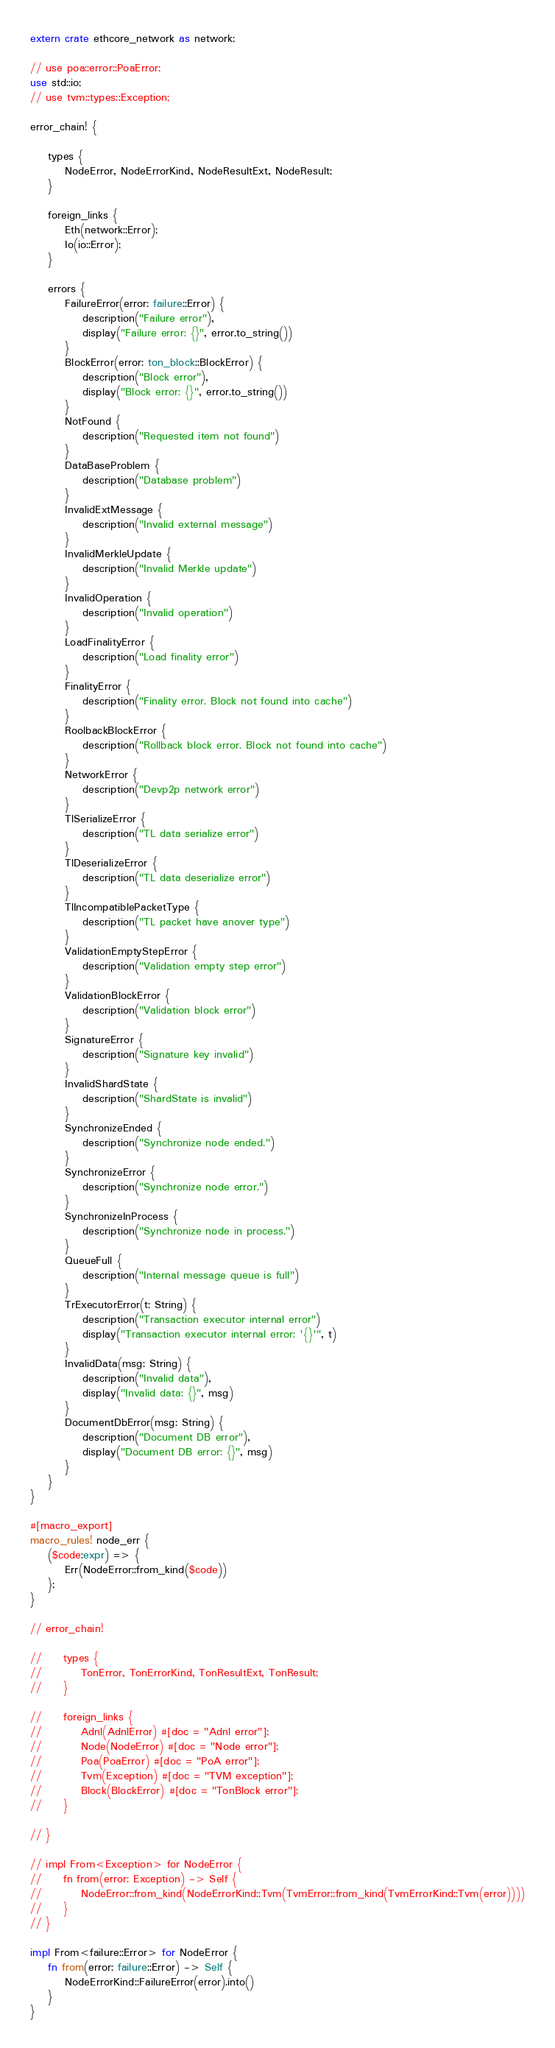Convert code to text. <code><loc_0><loc_0><loc_500><loc_500><_Rust_>extern crate ethcore_network as network;

// use poa::error::PoaError;
use std::io;
// use tvm::types::Exception;

error_chain! {

    types {
        NodeError, NodeErrorKind, NodeResultExt, NodeResult;
    }

    foreign_links {
        Eth(network::Error);
        Io(io::Error);
    }

    errors {
        FailureError(error: failure::Error) {
            description("Failure error"),
            display("Failure error: {}", error.to_string())
        }
        BlockError(error: ton_block::BlockError) {
            description("Block error"),
            display("Block error: {}", error.to_string())
        }
        NotFound {
            description("Requested item not found")
        }
        DataBaseProblem {
            description("Database problem")
        }
        InvalidExtMessage {
            description("Invalid external message")
        }
        InvalidMerkleUpdate {
            description("Invalid Merkle update")
        }
        InvalidOperation {
            description("Invalid operation")
        }
        LoadFinalityError {
            description("Load finality error")
        }
        FinalityError {
            description("Finality error. Block not found into cache")
        }
        RoolbackBlockError {
            description("Rollback block error. Block not found into cache")
        }
        NetworkError {
            description("Devp2p network error")
        }
        TlSerializeError {
            description("TL data serialize error")
        }
        TlDeserializeError {
            description("TL data deserialize error")
        }
        TlIncompatiblePacketType {
            description("TL packet have anover type")
        }
        ValidationEmptyStepError {
            description("Validation empty step error")
        }
        ValidationBlockError {
            description("Validation block error")
        }
        SignatureError {
            description("Signature key invalid")
        }
        InvalidShardState {
            description("ShardState is invalid")
        }
        SynchronizeEnded {
            description("Synchronize node ended.")
        }
        SynchronizeError {
            description("Synchronize node error.")
        }
        SynchronizeInProcess {
            description("Synchronize node in process.")
        }
        QueueFull {
            description("Internal message queue is full")
        }
        TrExecutorError(t: String) {
            description("Transaction executor internal error")
            display("Transaction executor internal error: '{}'", t)
        }
        InvalidData(msg: String) {
            description("Invalid data"),
            display("Invalid data: {}", msg)
        }
        DocumentDbError(msg: String) {
            description("Document DB error"),
            display("Document DB error: {}", msg)
        }
    }
}

#[macro_export]
macro_rules! node_err {
    ($code:expr) => {
        Err(NodeError::from_kind($code))
    };
}

// error_chain! 

//     types {
//         TonError, TonErrorKind, TonResultExt, TonResult;
//     }

//     foreign_links {
//         Adnl(AdnlError) #[doc = "Adnl error"];
//         Node(NodeError) #[doc = "Node error"];
//         Poa(PoaError) #[doc = "PoA error"];
//         Tvm(Exception) #[doc = "TVM exception"];
//         Block(BlockError) #[doc = "TonBlock error"];
//     }

// }

// impl From<Exception> for NodeError {
//     fn from(error: Exception) -> Self {
//         NodeError::from_kind(NodeErrorKind::Tvm(TvmError::from_kind(TvmErrorKind::Tvm(error))))
//     }
// }

impl From<failure::Error> for NodeError {
    fn from(error: failure::Error) -> Self {
        NodeErrorKind::FailureError(error).into()
    }
}
</code> 